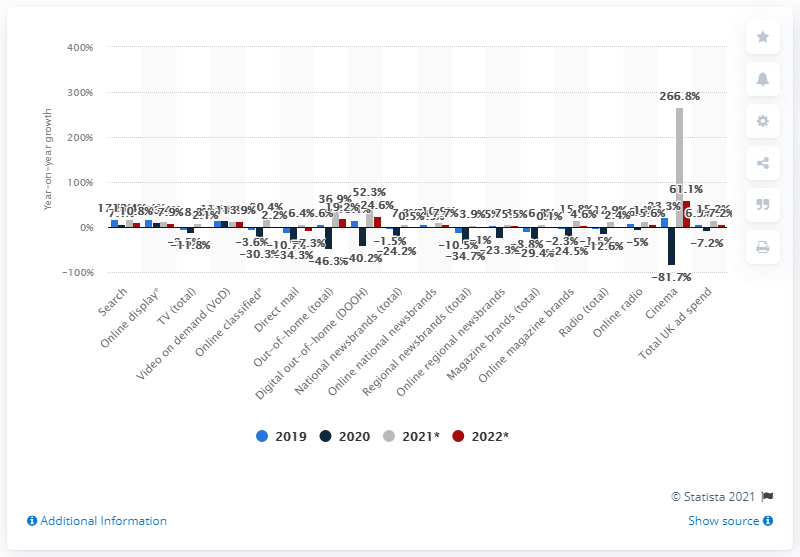Indicate a few pertinent items in this graphic. According to a forecast, online classifieds ad spend is expected to increase by 20.4% in 2021. Digital out-of-home is projected to expand by 52.3% in 2021, indicating a continued growth trend in the industry. 